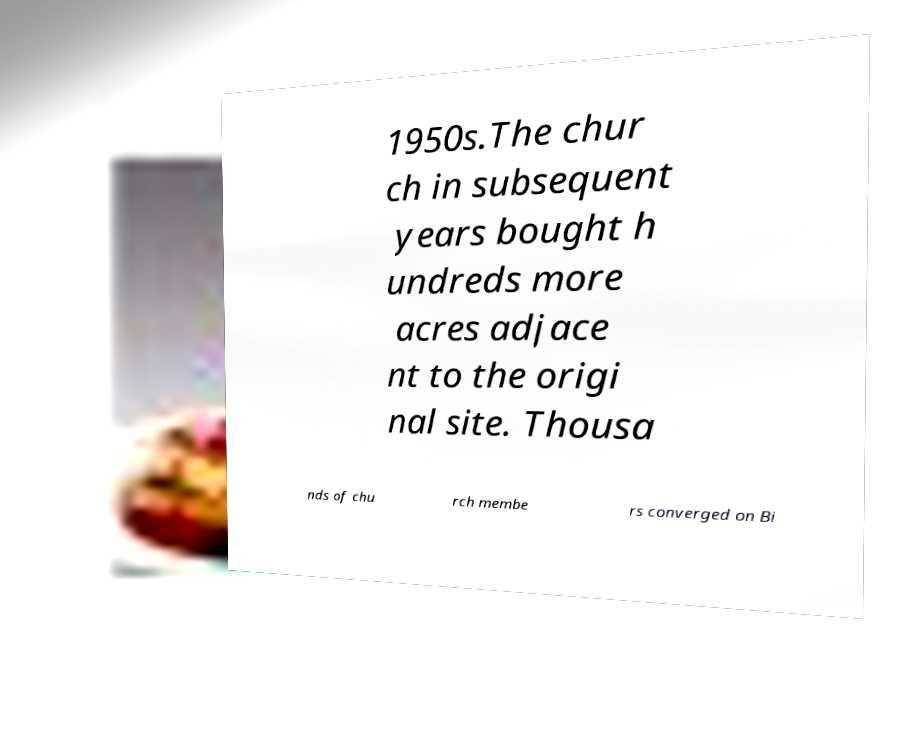Can you read and provide the text displayed in the image?This photo seems to have some interesting text. Can you extract and type it out for me? 1950s.The chur ch in subsequent years bought h undreds more acres adjace nt to the origi nal site. Thousa nds of chu rch membe rs converged on Bi 